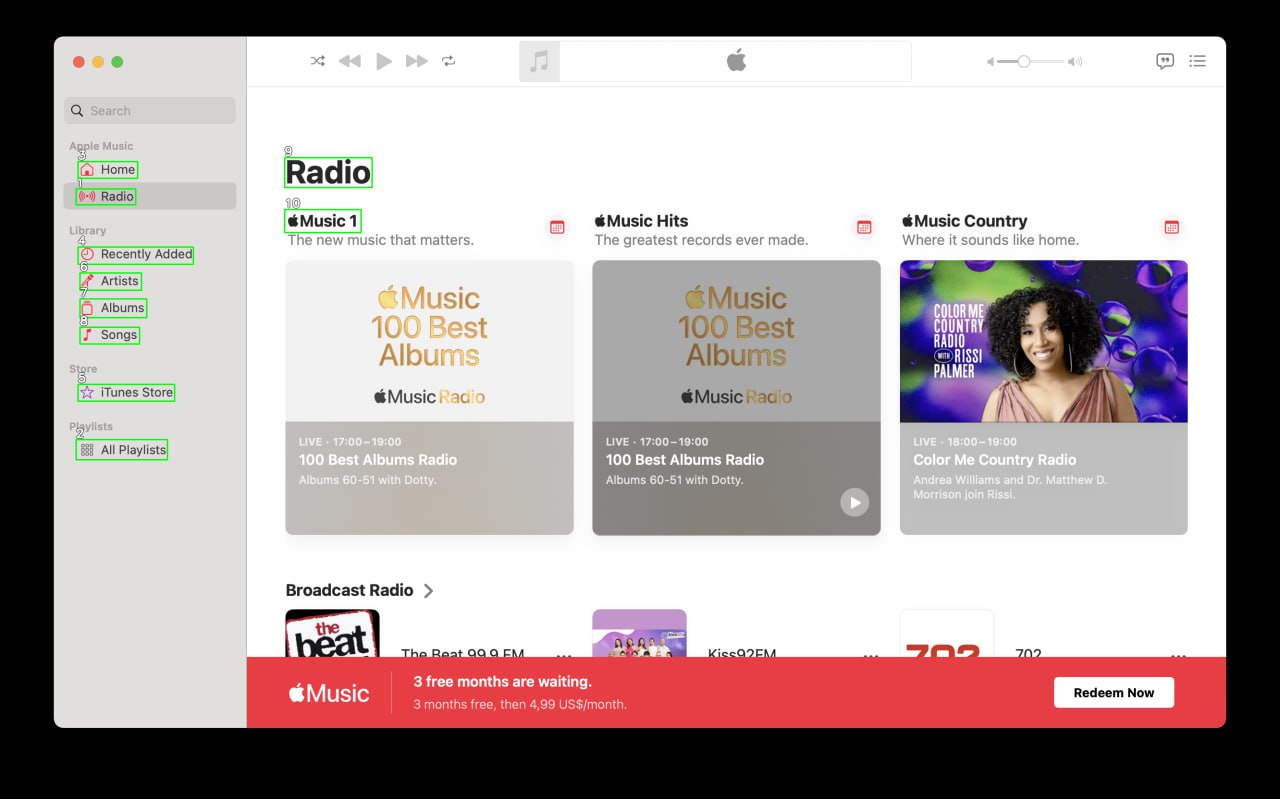Your task is to analyze the screenshot of the {app_name} on MacOS.  The screenshot is segmented with bounding boxes, each labeled with a number. The labels are always white numbers with a black outline. Number is always situated in the top left corner above the box. Describe each of the boxes numbered 1 to 10. For each identified element, provide a description that correlates with its functionality. If the element type is AXImage, write an alternative text describing the image content. Include text from the box if it is presented. Provide the output in the JSON format. ```json
{
  "1": {
    "description": "Search bar",
    "functionality": "Allows users to search for music within the app."
  },
  "2": {
    "description": "Home button",
    "functionality": "Navigates to the home section of the app."
  },
  "3": {
    "description": "Radio button",
    "functionality": "Navigates to the radio section of the app."
  },
  "4": {
    "description": "Recently Added button",
    "functionality": "Shows music that was recently added to the library."
  },
  "5": {
    "description": "Artists button",
    "functionality": "Displays a list of all artists in the library."
  },
  "6": {
    "description": "Albums button",
    "functionality": "Displays a list of all albums in the library."
  },
  "7": {
    "description": "Songs button",
    "functionality": "Displays a list of all songs in the library."
  },
  "8": {
    "description": "iTunes Store button",
    "functionality": "Navigates to the iTunes Store."
  },
  "9": {
    "description": "All Playlists button",
    "functionality": "Displays all playlists created by the user."
  },
  "10": {
    "description": "Music 1 section",
    "functionality": "Highlights the 'Music 1' radio station with a brief description: 'The new music that matters.'"
  }
}
``` 